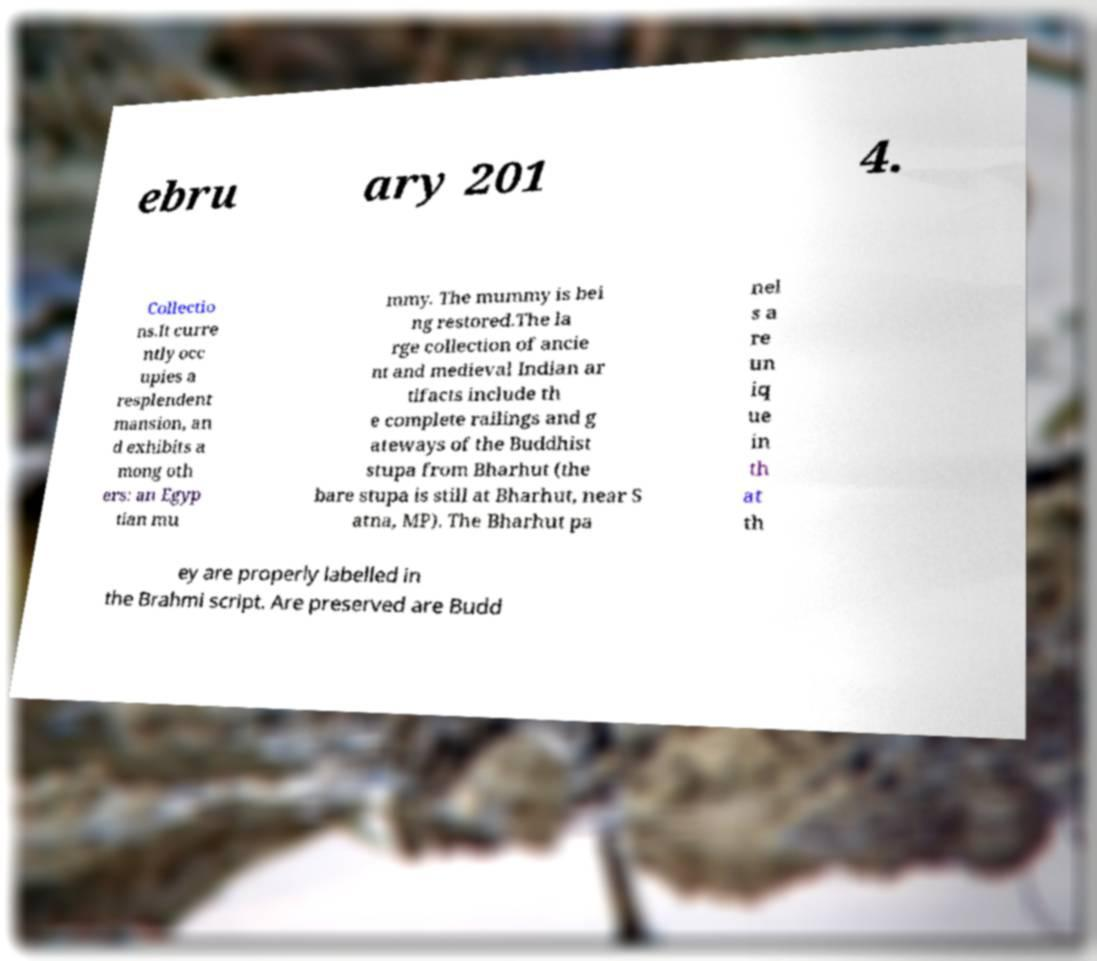Can you read and provide the text displayed in the image?This photo seems to have some interesting text. Can you extract and type it out for me? ebru ary 201 4. Collectio ns.It curre ntly occ upies a resplendent mansion, an d exhibits a mong oth ers: an Egyp tian mu mmy. The mummy is bei ng restored.The la rge collection of ancie nt and medieval Indian ar tifacts include th e complete railings and g ateways of the Buddhist stupa from Bharhut (the bare stupa is still at Bharhut, near S atna, MP). The Bharhut pa nel s a re un iq ue in th at th ey are properly labelled in the Brahmi script. Are preserved are Budd 